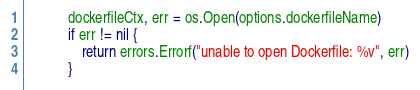<code> <loc_0><loc_0><loc_500><loc_500><_Go_>			dockerfileCtx, err = os.Open(options.dockerfileName)
			if err != nil {
				return errors.Errorf("unable to open Dockerfile: %v", err)
			}</code> 